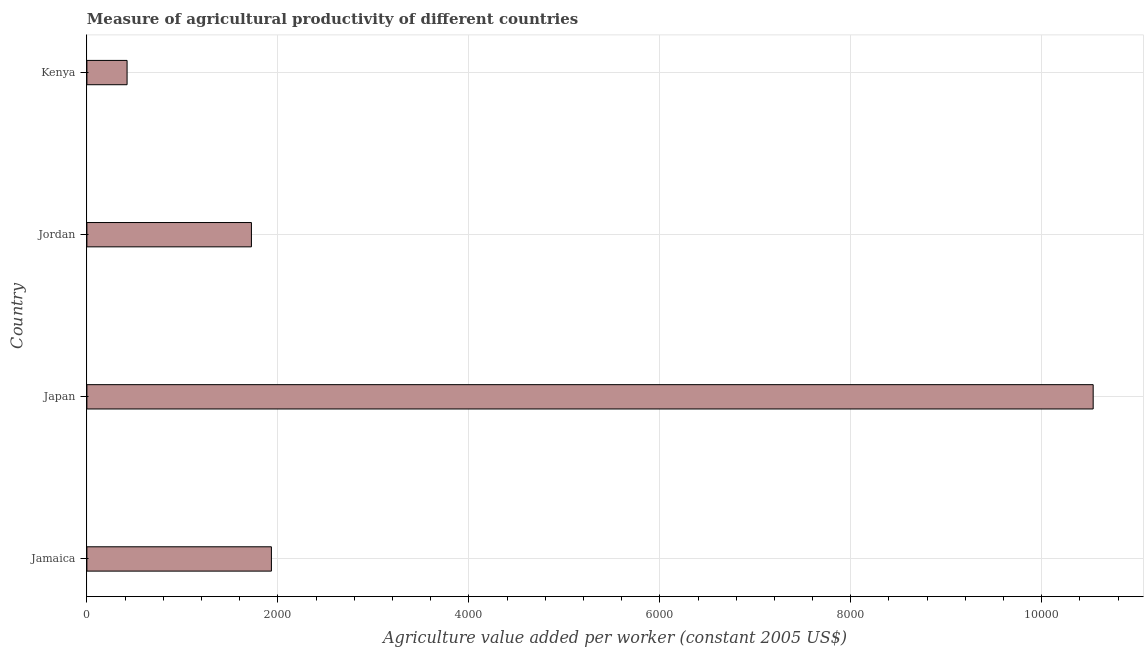What is the title of the graph?
Give a very brief answer. Measure of agricultural productivity of different countries. What is the label or title of the X-axis?
Make the answer very short. Agriculture value added per worker (constant 2005 US$). What is the agriculture value added per worker in Japan?
Your answer should be very brief. 1.05e+04. Across all countries, what is the maximum agriculture value added per worker?
Your answer should be compact. 1.05e+04. Across all countries, what is the minimum agriculture value added per worker?
Your answer should be very brief. 420.9. In which country was the agriculture value added per worker minimum?
Your answer should be very brief. Kenya. What is the sum of the agriculture value added per worker?
Provide a succinct answer. 1.46e+04. What is the difference between the agriculture value added per worker in Jamaica and Kenya?
Offer a terse response. 1511.45. What is the average agriculture value added per worker per country?
Your answer should be compact. 3653.72. What is the median agriculture value added per worker?
Keep it short and to the point. 1827.69. What is the ratio of the agriculture value added per worker in Jamaica to that in Japan?
Offer a very short reply. 0.18. What is the difference between the highest and the second highest agriculture value added per worker?
Ensure brevity in your answer.  8606.25. What is the difference between the highest and the lowest agriculture value added per worker?
Ensure brevity in your answer.  1.01e+04. In how many countries, is the agriculture value added per worker greater than the average agriculture value added per worker taken over all countries?
Your answer should be very brief. 1. How many bars are there?
Provide a short and direct response. 4. Are all the bars in the graph horizontal?
Your answer should be compact. Yes. What is the difference between two consecutive major ticks on the X-axis?
Offer a terse response. 2000. Are the values on the major ticks of X-axis written in scientific E-notation?
Keep it short and to the point. No. What is the Agriculture value added per worker (constant 2005 US$) of Jamaica?
Your answer should be compact. 1932.35. What is the Agriculture value added per worker (constant 2005 US$) of Japan?
Provide a succinct answer. 1.05e+04. What is the Agriculture value added per worker (constant 2005 US$) in Jordan?
Provide a short and direct response. 1723.02. What is the Agriculture value added per worker (constant 2005 US$) in Kenya?
Your answer should be very brief. 420.9. What is the difference between the Agriculture value added per worker (constant 2005 US$) in Jamaica and Japan?
Provide a short and direct response. -8606.25. What is the difference between the Agriculture value added per worker (constant 2005 US$) in Jamaica and Jordan?
Ensure brevity in your answer.  209.32. What is the difference between the Agriculture value added per worker (constant 2005 US$) in Jamaica and Kenya?
Offer a very short reply. 1511.45. What is the difference between the Agriculture value added per worker (constant 2005 US$) in Japan and Jordan?
Offer a very short reply. 8815.57. What is the difference between the Agriculture value added per worker (constant 2005 US$) in Japan and Kenya?
Ensure brevity in your answer.  1.01e+04. What is the difference between the Agriculture value added per worker (constant 2005 US$) in Jordan and Kenya?
Keep it short and to the point. 1302.13. What is the ratio of the Agriculture value added per worker (constant 2005 US$) in Jamaica to that in Japan?
Your answer should be very brief. 0.18. What is the ratio of the Agriculture value added per worker (constant 2005 US$) in Jamaica to that in Jordan?
Provide a short and direct response. 1.12. What is the ratio of the Agriculture value added per worker (constant 2005 US$) in Jamaica to that in Kenya?
Keep it short and to the point. 4.59. What is the ratio of the Agriculture value added per worker (constant 2005 US$) in Japan to that in Jordan?
Ensure brevity in your answer.  6.12. What is the ratio of the Agriculture value added per worker (constant 2005 US$) in Japan to that in Kenya?
Make the answer very short. 25.04. What is the ratio of the Agriculture value added per worker (constant 2005 US$) in Jordan to that in Kenya?
Provide a succinct answer. 4.09. 